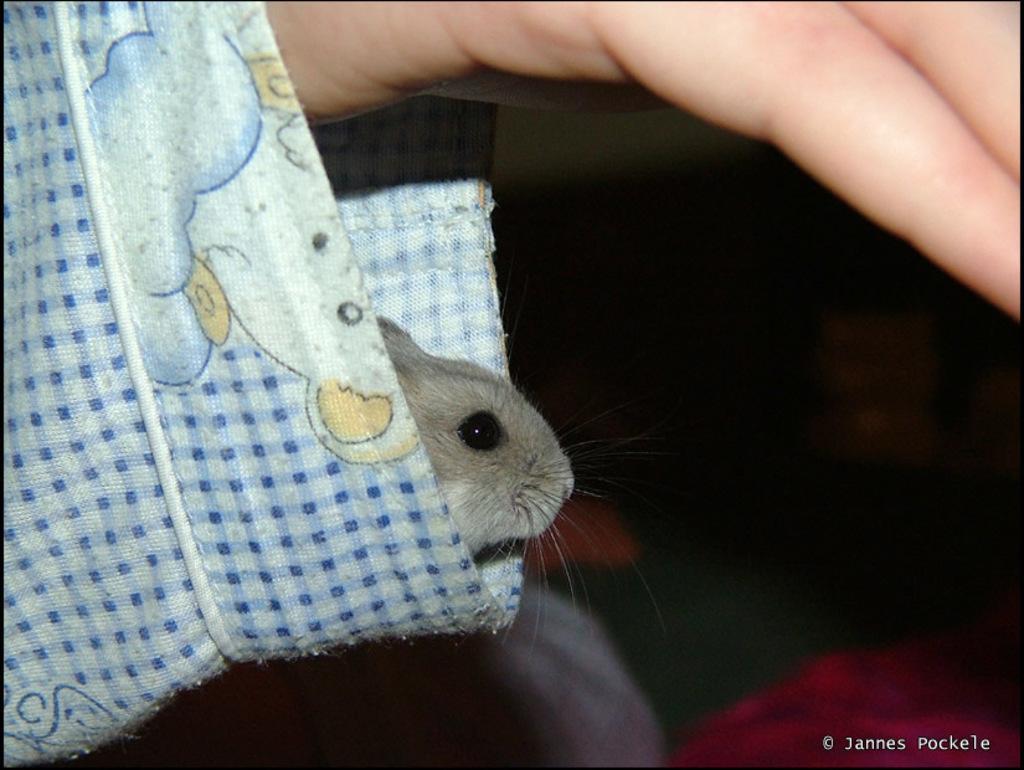Can you describe this image briefly? Here we can see a person hand and there is a rat in the sleeve of the person hand. In the background the image is not clear but we can see objects. 